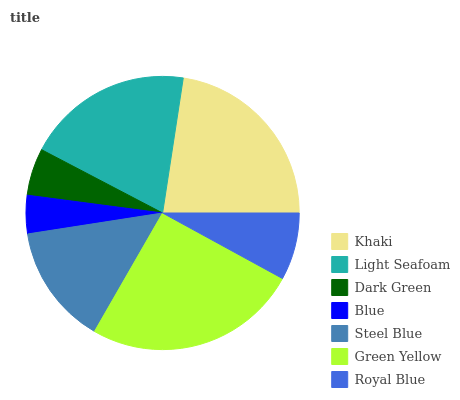Is Blue the minimum?
Answer yes or no. Yes. Is Green Yellow the maximum?
Answer yes or no. Yes. Is Light Seafoam the minimum?
Answer yes or no. No. Is Light Seafoam the maximum?
Answer yes or no. No. Is Khaki greater than Light Seafoam?
Answer yes or no. Yes. Is Light Seafoam less than Khaki?
Answer yes or no. Yes. Is Light Seafoam greater than Khaki?
Answer yes or no. No. Is Khaki less than Light Seafoam?
Answer yes or no. No. Is Steel Blue the high median?
Answer yes or no. Yes. Is Steel Blue the low median?
Answer yes or no. Yes. Is Blue the high median?
Answer yes or no. No. Is Light Seafoam the low median?
Answer yes or no. No. 